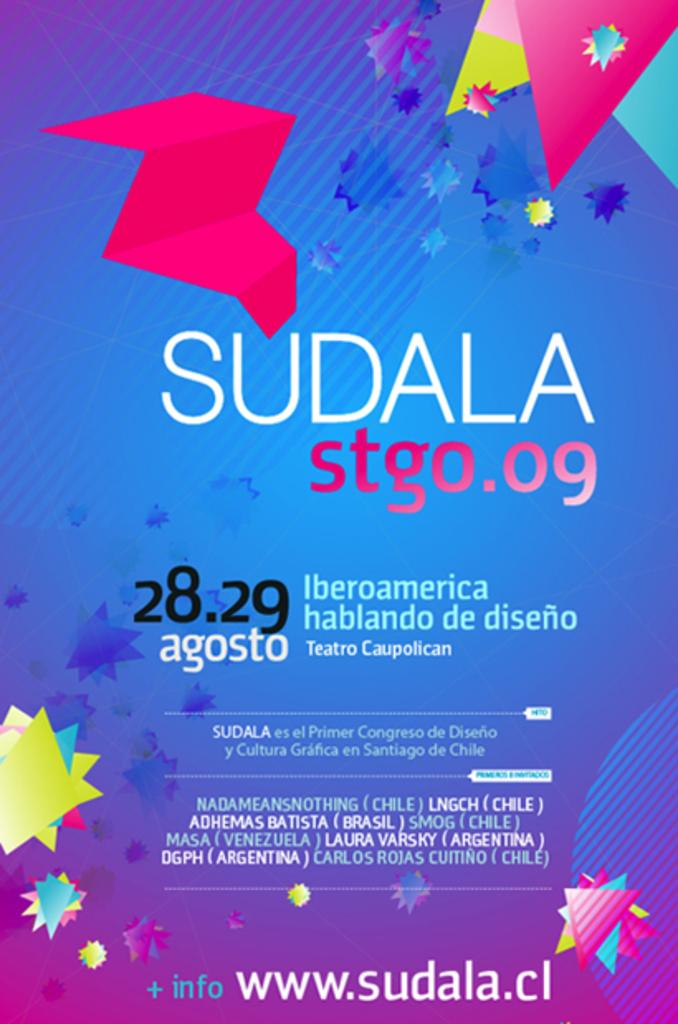<image>
Present a compact description of the photo's key features. A brightly colored poster that says Sudala on it. 